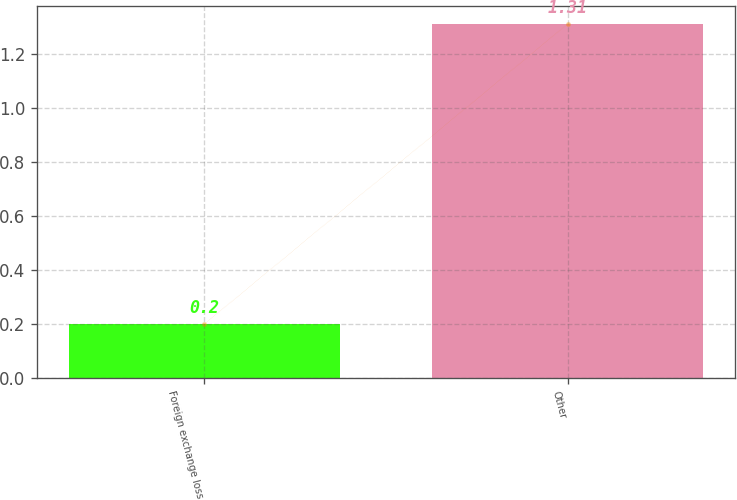Convert chart. <chart><loc_0><loc_0><loc_500><loc_500><bar_chart><fcel>Foreign exchange loss<fcel>Other<nl><fcel>0.2<fcel>1.31<nl></chart> 